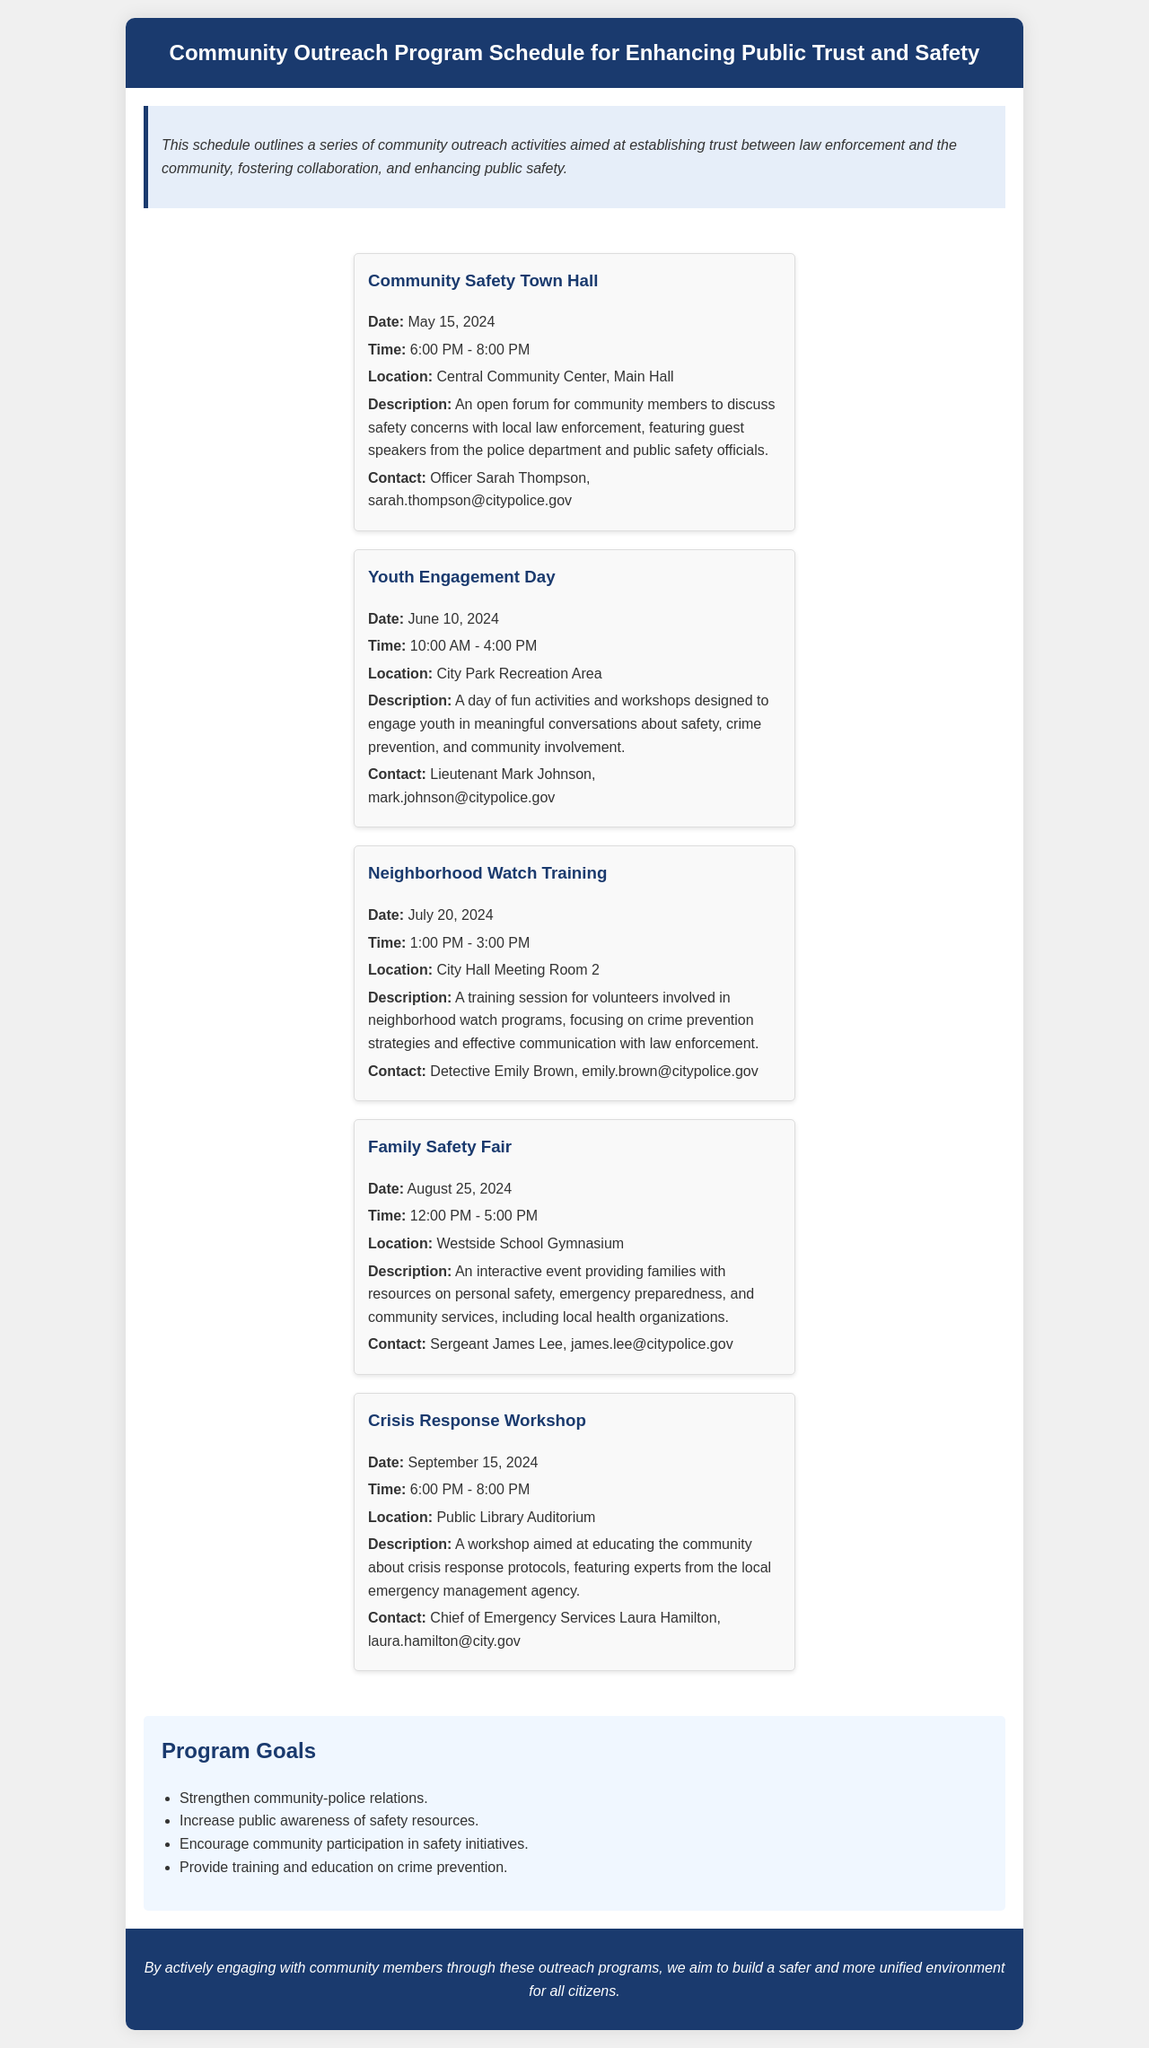What is the date of the Community Safety Town Hall? The date is specified in the event description of the Community Safety Town Hall.
Answer: May 15, 2024 What is the time of the Family Safety Fair? The time is provided in the event details of the Family Safety Fair.
Answer: 12:00 PM - 5:00 PM Who should be contacted for the Neighborhood Watch Training? The contact person is listed in the Neighborhood Watch Training event details.
Answer: Detective Emily Brown How many goals are listed in the program goals? The number of goals can be counted from the bulleted list under Program Goals.
Answer: 4 What type of event is scheduled for September 15, 2024? The type of event is specified in the event title for that date.
Answer: Crisis Response Workshop What is the location of the Youth Engagement Day? The location is provided in the details of the Youth Engagement Day event.
Answer: City Park Recreation Area Which event occurs just before the Family Safety Fair? The relationship between the events in the schedule indicates the order.
Answer: Neighborhood Watch Training What is the main focus of the Community Outreach Program? The focus is described in the overview at the beginning of the document.
Answer: Establishing trust between law enforcement and the community 